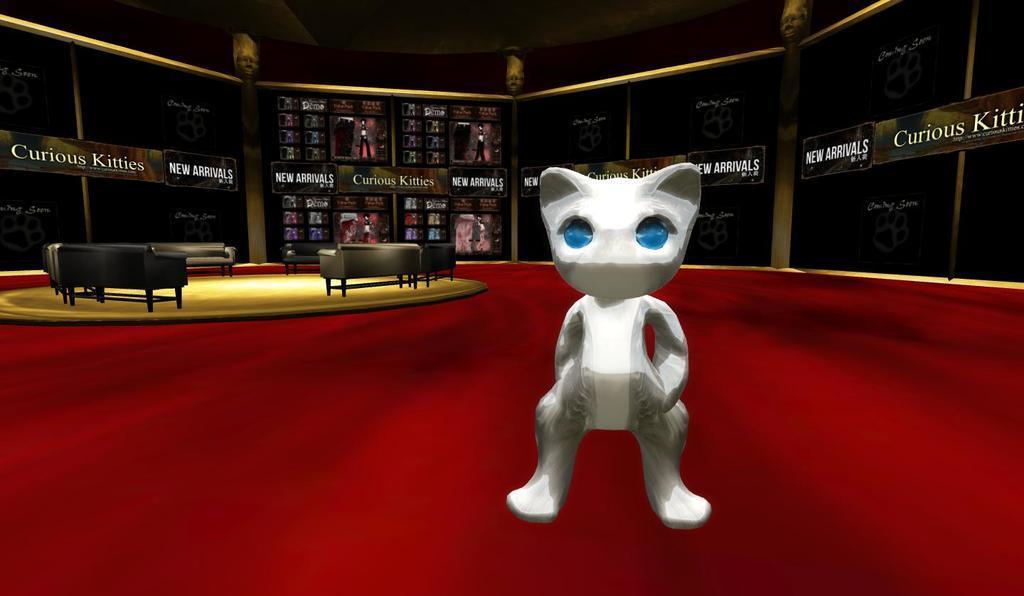In one or two sentences, can you explain what this image depicts? This looks like an edited image. This is a cat, which is white in color. These are the couches. I can see the name boards and posters in the background. This looks like a red carpet. 